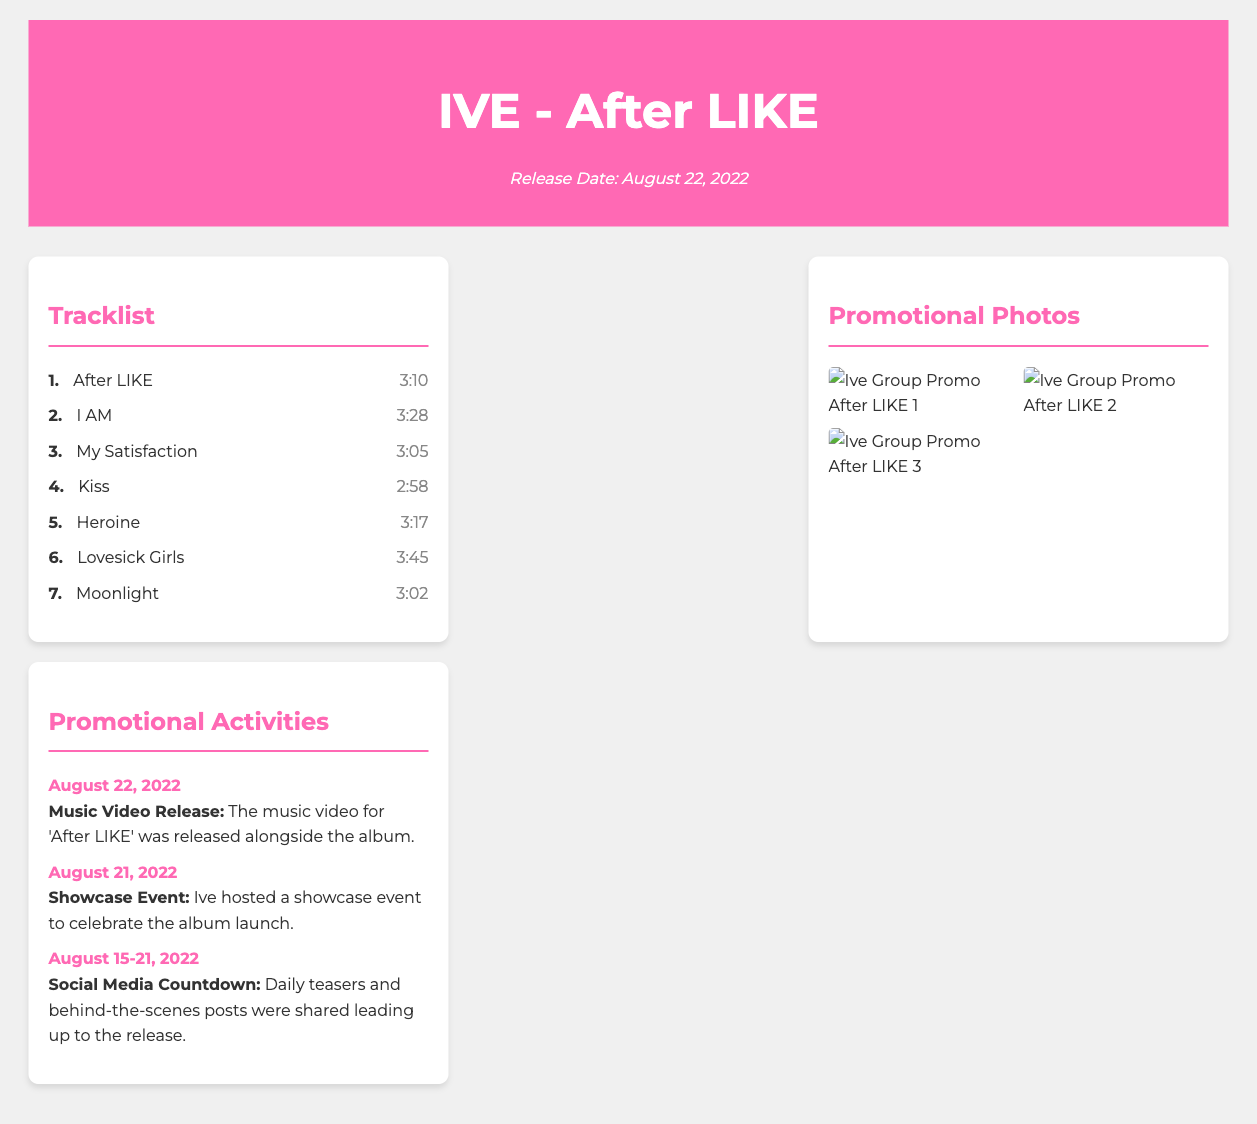What is the release date of the album? The release date is explicitly mentioned in the header of the document.
Answer: August 22, 2022 How many tracks are included in the album? The tracklist section lists the total number of tracks.
Answer: 7 What is the duration of the track "Kiss"? The duration is specified next to the track name in the tracklist.
Answer: 2:58 What type of event was held on August 21, 2022? This information is found in the promotional activities section under the respective date.
Answer: Showcase Event Which track has the longest duration? Reasoning involves comparing the durations of all tracks listed in the tracklist.
Answer: Lovesick Girls What promotional activity took place before the album release? It's mentioned in the promotional activities section with the date range.
Answer: Social Media Countdown How many promotional photos are displayed? The number of images can be counted in the promotional photos section.
Answer: 3 What is the title of the first track? The title can be found at the beginning of the tracklist provided.
Answer: After LIKE What color is the header of the document? The color is indicated in the style section dedicated to the header.
Answer: Pink 